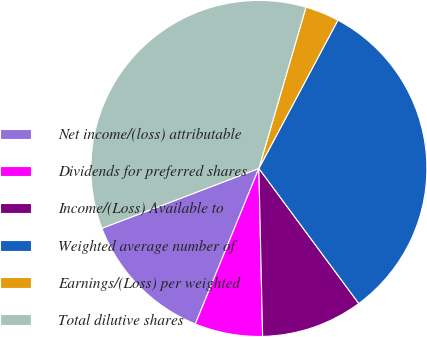Convert chart to OTSL. <chart><loc_0><loc_0><loc_500><loc_500><pie_chart><fcel>Net income/(loss) attributable<fcel>Dividends for preferred shares<fcel>Income/(Loss) Available to<fcel>Weighted average number of<fcel>Earnings/(Loss) per weighted<fcel>Total dilutive shares<nl><fcel>13.03%<fcel>6.53%<fcel>9.78%<fcel>32.07%<fcel>3.27%<fcel>35.32%<nl></chart> 